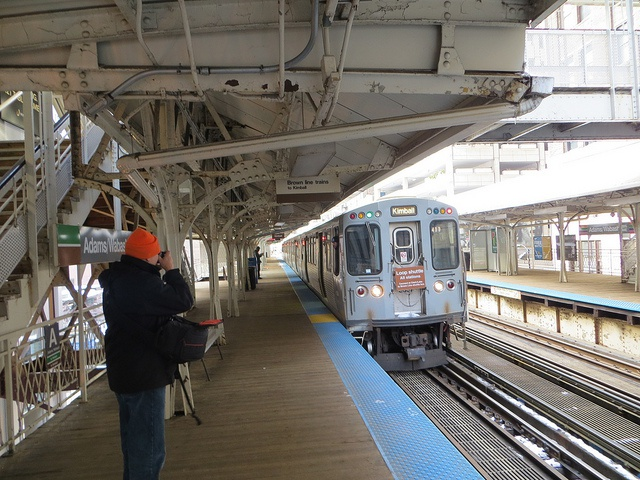Describe the objects in this image and their specific colors. I can see train in black, gray, and darkgray tones, people in black, brown, maroon, and gray tones, backpack in black and gray tones, and people in black, gray, darkgray, and lightgray tones in this image. 